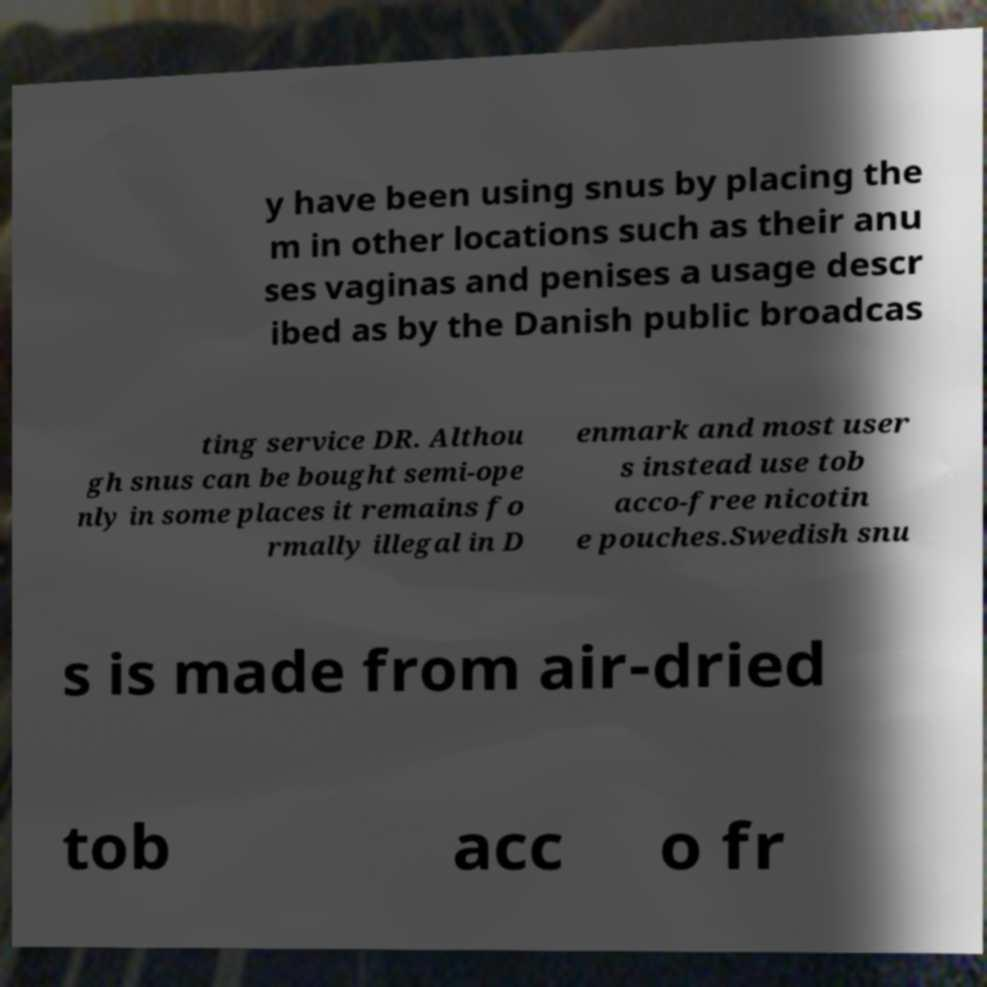Please read and relay the text visible in this image. What does it say? y have been using snus by placing the m in other locations such as their anu ses vaginas and penises a usage descr ibed as by the Danish public broadcas ting service DR. Althou gh snus can be bought semi-ope nly in some places it remains fo rmally illegal in D enmark and most user s instead use tob acco-free nicotin e pouches.Swedish snu s is made from air-dried tob acc o fr 